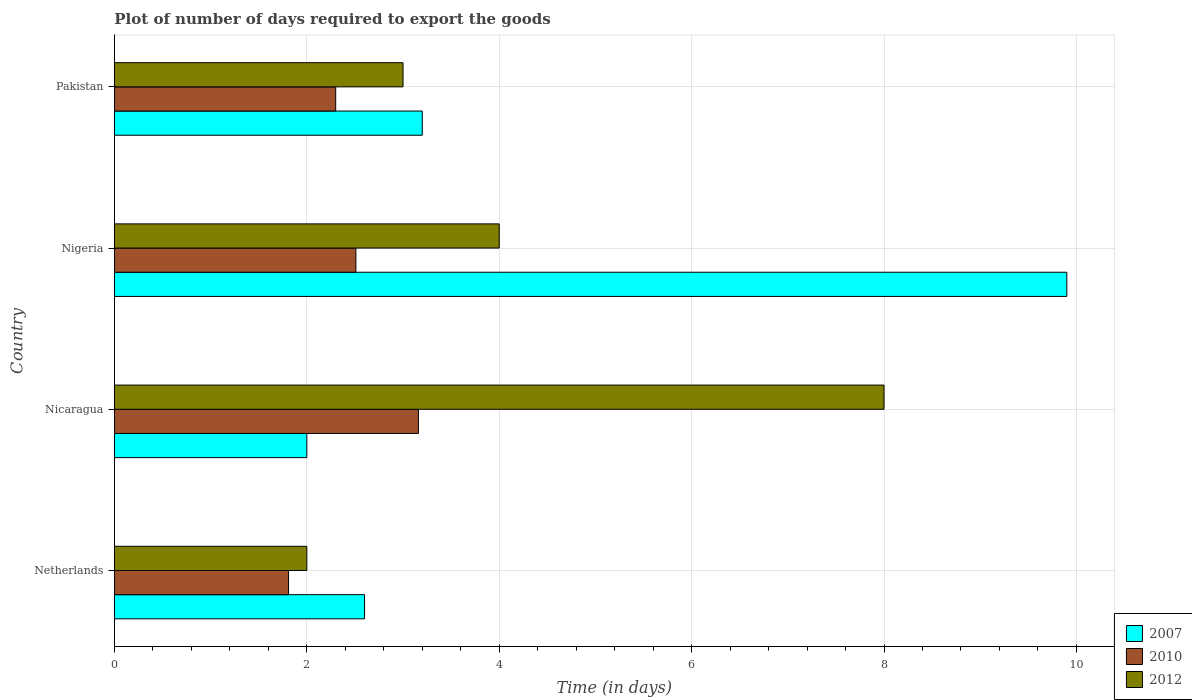How many different coloured bars are there?
Keep it short and to the point. 3. How many groups of bars are there?
Ensure brevity in your answer.  4. Are the number of bars per tick equal to the number of legend labels?
Your answer should be compact. Yes. Are the number of bars on each tick of the Y-axis equal?
Make the answer very short. Yes. How many bars are there on the 4th tick from the top?
Give a very brief answer. 3. In how many cases, is the number of bars for a given country not equal to the number of legend labels?
Your response must be concise. 0. What is the time required to export goods in 2007 in Netherlands?
Provide a succinct answer. 2.6. Across all countries, what is the maximum time required to export goods in 2010?
Your answer should be compact. 3.16. Across all countries, what is the minimum time required to export goods in 2010?
Provide a short and direct response. 1.81. In which country was the time required to export goods in 2012 maximum?
Your response must be concise. Nicaragua. In which country was the time required to export goods in 2007 minimum?
Offer a terse response. Nicaragua. What is the difference between the time required to export goods in 2012 in Netherlands and that in Nicaragua?
Provide a short and direct response. -6. What is the difference between the time required to export goods in 2007 in Nicaragua and the time required to export goods in 2012 in Pakistan?
Ensure brevity in your answer.  -1. What is the average time required to export goods in 2007 per country?
Provide a short and direct response. 4.42. What is the difference between the time required to export goods in 2007 and time required to export goods in 2012 in Nigeria?
Your answer should be very brief. 5.9. What is the ratio of the time required to export goods in 2010 in Nicaragua to that in Nigeria?
Keep it short and to the point. 1.26. Is the time required to export goods in 2007 in Nicaragua less than that in Pakistan?
Give a very brief answer. Yes. Is the difference between the time required to export goods in 2007 in Nicaragua and Pakistan greater than the difference between the time required to export goods in 2012 in Nicaragua and Pakistan?
Provide a short and direct response. No. What is the difference between the highest and the second highest time required to export goods in 2012?
Give a very brief answer. 4. What is the difference between the highest and the lowest time required to export goods in 2010?
Provide a short and direct response. 1.35. In how many countries, is the time required to export goods in 2010 greater than the average time required to export goods in 2010 taken over all countries?
Keep it short and to the point. 2. Is the sum of the time required to export goods in 2012 in Nicaragua and Nigeria greater than the maximum time required to export goods in 2010 across all countries?
Make the answer very short. Yes. What does the 1st bar from the top in Netherlands represents?
Provide a short and direct response. 2012. Is it the case that in every country, the sum of the time required to export goods in 2010 and time required to export goods in 2012 is greater than the time required to export goods in 2007?
Your answer should be compact. No. Are all the bars in the graph horizontal?
Ensure brevity in your answer.  Yes. Does the graph contain grids?
Keep it short and to the point. Yes. What is the title of the graph?
Ensure brevity in your answer.  Plot of number of days required to export the goods. Does "1983" appear as one of the legend labels in the graph?
Provide a succinct answer. No. What is the label or title of the X-axis?
Ensure brevity in your answer.  Time (in days). What is the label or title of the Y-axis?
Your response must be concise. Country. What is the Time (in days) of 2007 in Netherlands?
Offer a terse response. 2.6. What is the Time (in days) in 2010 in Netherlands?
Ensure brevity in your answer.  1.81. What is the Time (in days) of 2010 in Nicaragua?
Provide a short and direct response. 3.16. What is the Time (in days) of 2012 in Nicaragua?
Your answer should be very brief. 8. What is the Time (in days) in 2010 in Nigeria?
Ensure brevity in your answer.  2.51. What is the Time (in days) of 2012 in Nigeria?
Make the answer very short. 4. What is the Time (in days) of 2007 in Pakistan?
Offer a terse response. 3.2. What is the Time (in days) of 2012 in Pakistan?
Your response must be concise. 3. Across all countries, what is the maximum Time (in days) in 2010?
Ensure brevity in your answer.  3.16. Across all countries, what is the minimum Time (in days) in 2010?
Provide a succinct answer. 1.81. What is the total Time (in days) in 2007 in the graph?
Give a very brief answer. 17.7. What is the total Time (in days) in 2010 in the graph?
Provide a succinct answer. 9.78. What is the difference between the Time (in days) in 2010 in Netherlands and that in Nicaragua?
Your answer should be very brief. -1.35. What is the difference between the Time (in days) in 2012 in Netherlands and that in Nicaragua?
Offer a very short reply. -6. What is the difference between the Time (in days) of 2007 in Netherlands and that in Nigeria?
Offer a terse response. -7.3. What is the difference between the Time (in days) of 2010 in Netherlands and that in Nigeria?
Your response must be concise. -0.7. What is the difference between the Time (in days) in 2012 in Netherlands and that in Nigeria?
Offer a terse response. -2. What is the difference between the Time (in days) of 2007 in Netherlands and that in Pakistan?
Keep it short and to the point. -0.6. What is the difference between the Time (in days) in 2010 in Netherlands and that in Pakistan?
Your response must be concise. -0.49. What is the difference between the Time (in days) in 2010 in Nicaragua and that in Nigeria?
Offer a terse response. 0.65. What is the difference between the Time (in days) of 2012 in Nicaragua and that in Nigeria?
Your response must be concise. 4. What is the difference between the Time (in days) in 2010 in Nicaragua and that in Pakistan?
Make the answer very short. 0.86. What is the difference between the Time (in days) in 2012 in Nicaragua and that in Pakistan?
Give a very brief answer. 5. What is the difference between the Time (in days) in 2010 in Nigeria and that in Pakistan?
Give a very brief answer. 0.21. What is the difference between the Time (in days) of 2007 in Netherlands and the Time (in days) of 2010 in Nicaragua?
Offer a terse response. -0.56. What is the difference between the Time (in days) of 2010 in Netherlands and the Time (in days) of 2012 in Nicaragua?
Provide a short and direct response. -6.19. What is the difference between the Time (in days) in 2007 in Netherlands and the Time (in days) in 2010 in Nigeria?
Your answer should be compact. 0.09. What is the difference between the Time (in days) in 2010 in Netherlands and the Time (in days) in 2012 in Nigeria?
Your answer should be compact. -2.19. What is the difference between the Time (in days) in 2007 in Netherlands and the Time (in days) in 2010 in Pakistan?
Ensure brevity in your answer.  0.3. What is the difference between the Time (in days) in 2010 in Netherlands and the Time (in days) in 2012 in Pakistan?
Offer a very short reply. -1.19. What is the difference between the Time (in days) of 2007 in Nicaragua and the Time (in days) of 2010 in Nigeria?
Your answer should be compact. -0.51. What is the difference between the Time (in days) of 2010 in Nicaragua and the Time (in days) of 2012 in Nigeria?
Your answer should be very brief. -0.84. What is the difference between the Time (in days) of 2007 in Nicaragua and the Time (in days) of 2010 in Pakistan?
Offer a terse response. -0.3. What is the difference between the Time (in days) of 2010 in Nicaragua and the Time (in days) of 2012 in Pakistan?
Offer a very short reply. 0.16. What is the difference between the Time (in days) in 2007 in Nigeria and the Time (in days) in 2010 in Pakistan?
Ensure brevity in your answer.  7.6. What is the difference between the Time (in days) of 2010 in Nigeria and the Time (in days) of 2012 in Pakistan?
Give a very brief answer. -0.49. What is the average Time (in days) of 2007 per country?
Provide a succinct answer. 4.42. What is the average Time (in days) in 2010 per country?
Your answer should be very brief. 2.44. What is the average Time (in days) in 2012 per country?
Keep it short and to the point. 4.25. What is the difference between the Time (in days) of 2007 and Time (in days) of 2010 in Netherlands?
Your answer should be compact. 0.79. What is the difference between the Time (in days) in 2010 and Time (in days) in 2012 in Netherlands?
Provide a succinct answer. -0.19. What is the difference between the Time (in days) in 2007 and Time (in days) in 2010 in Nicaragua?
Keep it short and to the point. -1.16. What is the difference between the Time (in days) of 2007 and Time (in days) of 2012 in Nicaragua?
Keep it short and to the point. -6. What is the difference between the Time (in days) of 2010 and Time (in days) of 2012 in Nicaragua?
Give a very brief answer. -4.84. What is the difference between the Time (in days) in 2007 and Time (in days) in 2010 in Nigeria?
Your response must be concise. 7.39. What is the difference between the Time (in days) of 2007 and Time (in days) of 2012 in Nigeria?
Make the answer very short. 5.9. What is the difference between the Time (in days) in 2010 and Time (in days) in 2012 in Nigeria?
Keep it short and to the point. -1.49. What is the difference between the Time (in days) of 2007 and Time (in days) of 2010 in Pakistan?
Offer a very short reply. 0.9. What is the difference between the Time (in days) of 2007 and Time (in days) of 2012 in Pakistan?
Provide a succinct answer. 0.2. What is the difference between the Time (in days) in 2010 and Time (in days) in 2012 in Pakistan?
Offer a terse response. -0.7. What is the ratio of the Time (in days) in 2007 in Netherlands to that in Nicaragua?
Offer a terse response. 1.3. What is the ratio of the Time (in days) in 2010 in Netherlands to that in Nicaragua?
Keep it short and to the point. 0.57. What is the ratio of the Time (in days) in 2012 in Netherlands to that in Nicaragua?
Give a very brief answer. 0.25. What is the ratio of the Time (in days) in 2007 in Netherlands to that in Nigeria?
Give a very brief answer. 0.26. What is the ratio of the Time (in days) of 2010 in Netherlands to that in Nigeria?
Keep it short and to the point. 0.72. What is the ratio of the Time (in days) in 2007 in Netherlands to that in Pakistan?
Give a very brief answer. 0.81. What is the ratio of the Time (in days) of 2010 in Netherlands to that in Pakistan?
Offer a terse response. 0.79. What is the ratio of the Time (in days) of 2012 in Netherlands to that in Pakistan?
Your answer should be very brief. 0.67. What is the ratio of the Time (in days) in 2007 in Nicaragua to that in Nigeria?
Make the answer very short. 0.2. What is the ratio of the Time (in days) of 2010 in Nicaragua to that in Nigeria?
Make the answer very short. 1.26. What is the ratio of the Time (in days) in 2012 in Nicaragua to that in Nigeria?
Your answer should be compact. 2. What is the ratio of the Time (in days) of 2010 in Nicaragua to that in Pakistan?
Provide a short and direct response. 1.37. What is the ratio of the Time (in days) in 2012 in Nicaragua to that in Pakistan?
Provide a short and direct response. 2.67. What is the ratio of the Time (in days) in 2007 in Nigeria to that in Pakistan?
Ensure brevity in your answer.  3.09. What is the ratio of the Time (in days) of 2010 in Nigeria to that in Pakistan?
Provide a short and direct response. 1.09. What is the ratio of the Time (in days) of 2012 in Nigeria to that in Pakistan?
Make the answer very short. 1.33. What is the difference between the highest and the second highest Time (in days) in 2010?
Offer a terse response. 0.65. What is the difference between the highest and the second highest Time (in days) in 2012?
Your answer should be compact. 4. What is the difference between the highest and the lowest Time (in days) in 2007?
Provide a succinct answer. 7.9. What is the difference between the highest and the lowest Time (in days) in 2010?
Your response must be concise. 1.35. What is the difference between the highest and the lowest Time (in days) in 2012?
Your response must be concise. 6. 